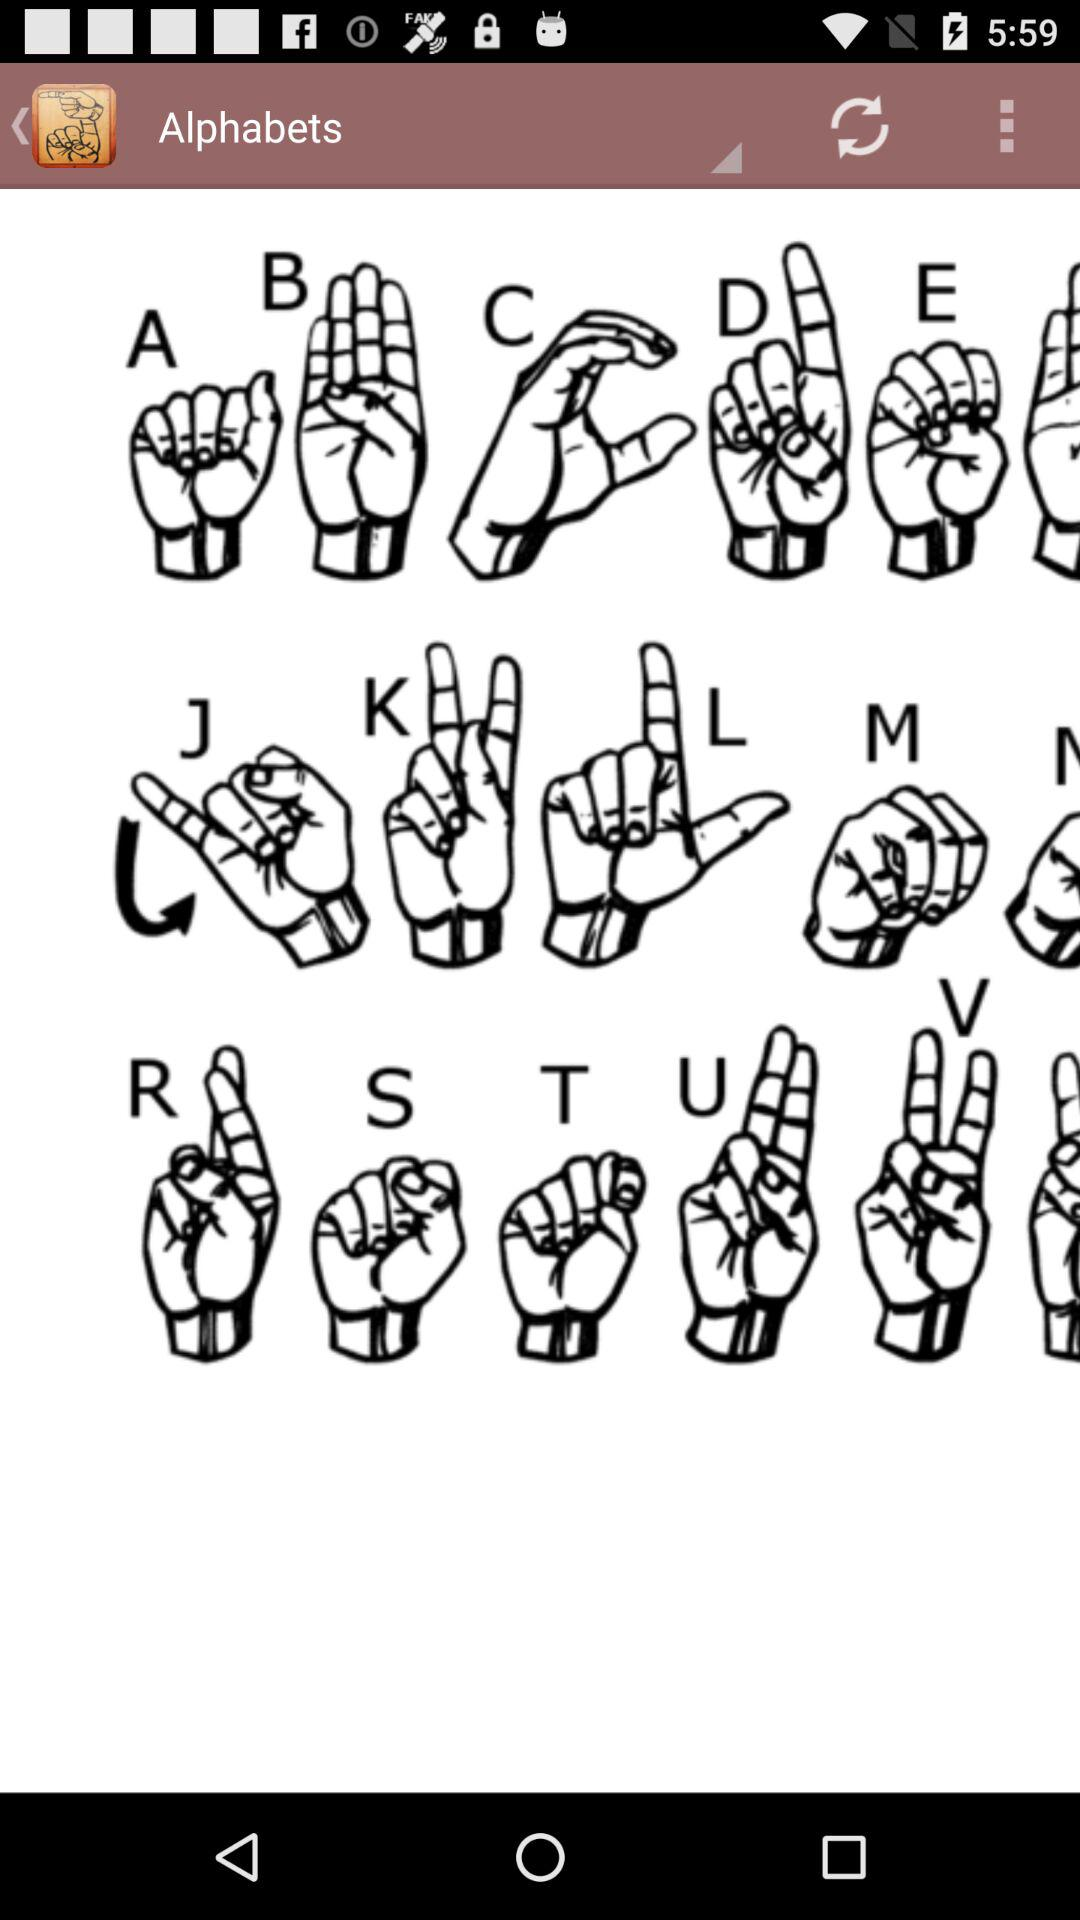What is the application name? The application name is "Alphabets". 